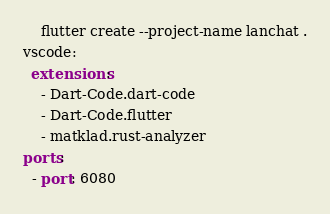<code> <loc_0><loc_0><loc_500><loc_500><_YAML_>    flutter create --project-name lanchat .
vscode:
  extensions:
    - Dart-Code.dart-code
    - Dart-Code.flutter
    - matklad.rust-analyzer
ports:
  - port: 6080
</code> 